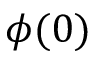<formula> <loc_0><loc_0><loc_500><loc_500>\phi ( 0 )</formula> 